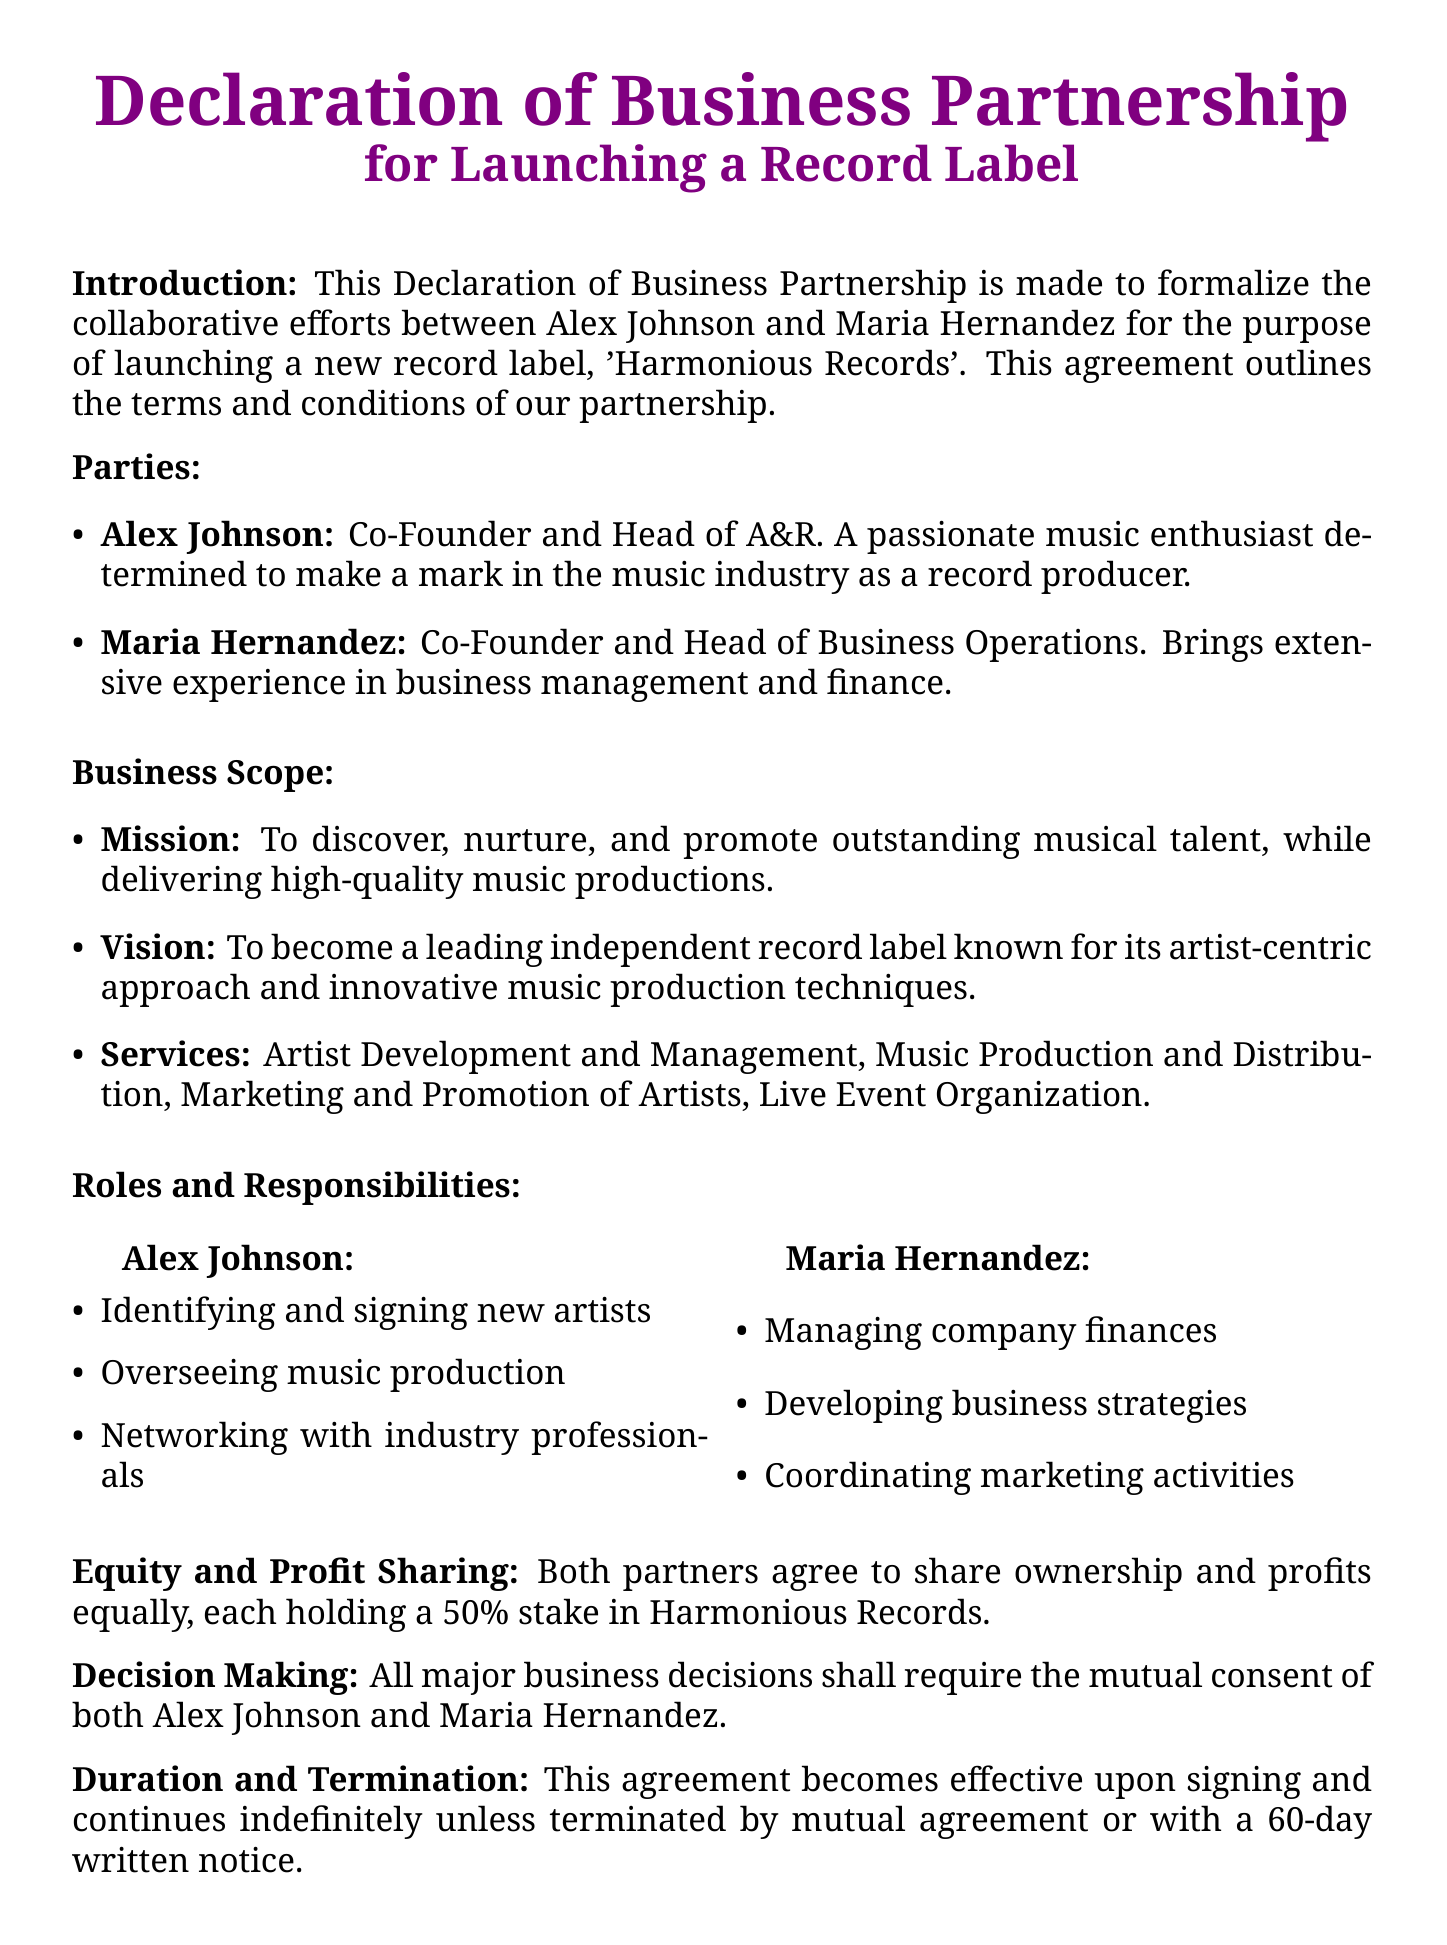What is the name of the record label? The name of the record label outlined in the document is 'Harmonious Records'.
Answer: Harmonious Records Who are the co-founders of the record label? The document states that the co-founders are Alex Johnson and Maria Hernandez.
Answer: Alex Johnson and Maria Hernandez What is Alex Johnson's role in the partnership? Alex Johnson's role is specified as Co-Founder and Head of A&R.
Answer: Co-Founder and Head of A&R What percentage of the company do both partners hold? The document indicates that both partners hold a 50% stake in the company.
Answer: 50% What is one service provided by Harmonious Records? The document lists several services, one of which is Music Production and Distribution.
Answer: Music Production and Distribution What is required for major business decisions? The document states that major business decisions require mutual consent of both partners.
Answer: Mutual consent How long is the notice period for termination of the agreement? The termination notice period mentioned in the document is 60 days.
Answer: 60 days What must happen for the agreement to take effect? The agreement must be signed by both partners to take effect.
Answer: Signed What is the mission of Harmonious Records? The mission outlined in the document is to discover, nurture, and promote outstanding musical talent.
Answer: Discover, nurture, and promote outstanding musical talent 